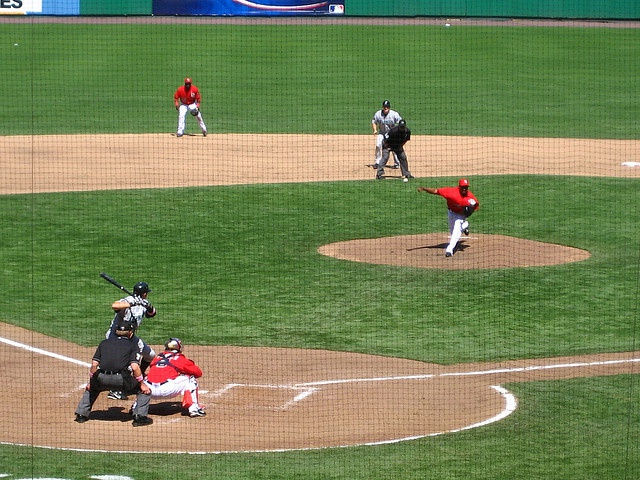Describe the objects in this image and their specific colors. I can see people in gray, black, and brown tones, people in gray, white, red, and salmon tones, people in gray, white, black, red, and maroon tones, people in gray, black, white, and darkgray tones, and people in gray and black tones in this image. 